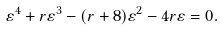Convert formula to latex. <formula><loc_0><loc_0><loc_500><loc_500>\varepsilon ^ { 4 } + r \varepsilon ^ { 3 } - ( r + 8 ) \varepsilon ^ { 2 } - 4 r \varepsilon = 0 .</formula> 